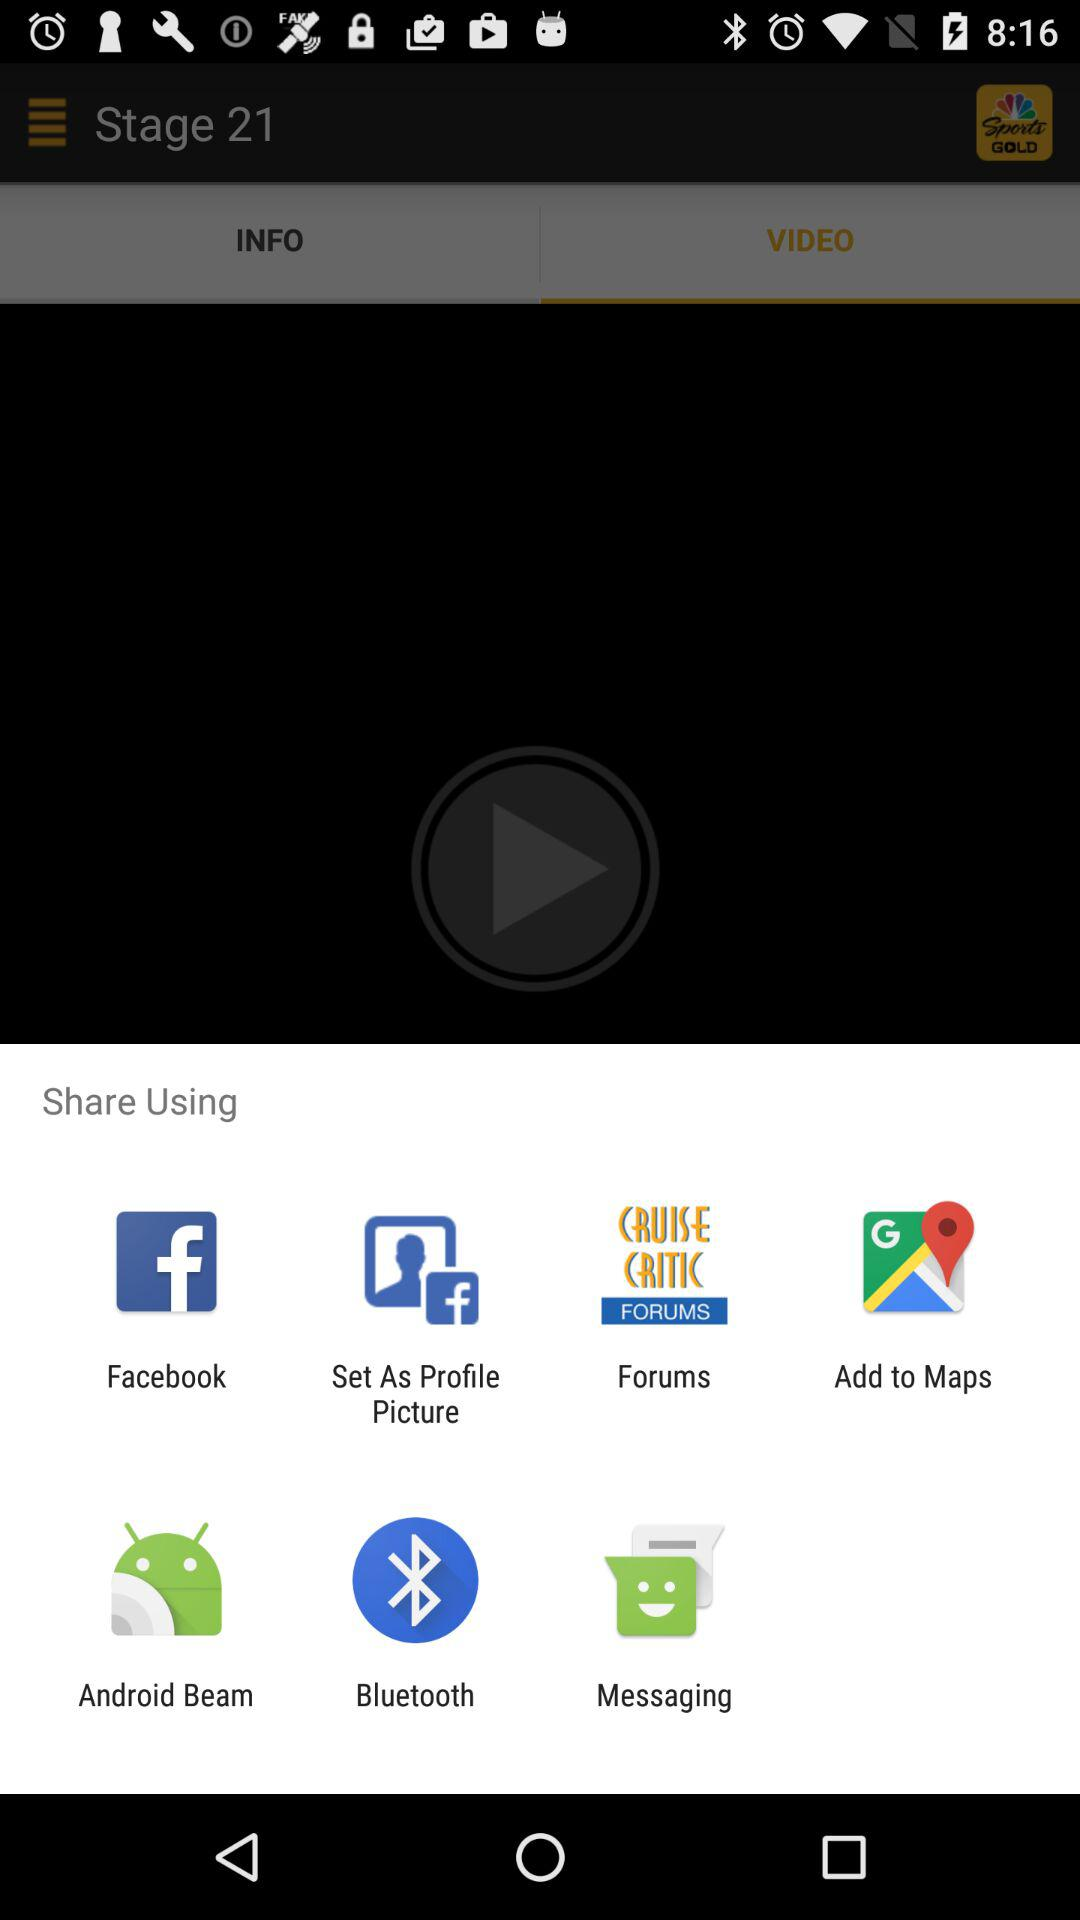How many items are in "INFO"?
When the provided information is insufficient, respond with <no answer>. <no answer> 